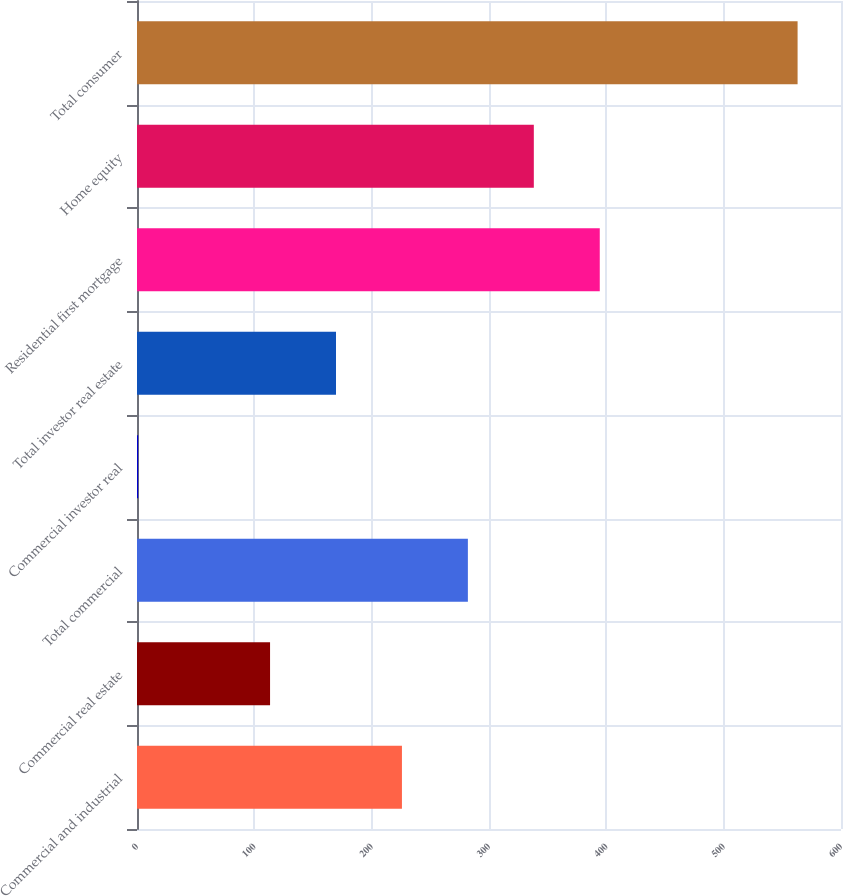<chart> <loc_0><loc_0><loc_500><loc_500><bar_chart><fcel>Commercial and industrial<fcel>Commercial real estate<fcel>Total commercial<fcel>Commercial investor real<fcel>Total investor real estate<fcel>Residential first mortgage<fcel>Home equity<fcel>Total consumer<nl><fcel>225.8<fcel>113.4<fcel>282<fcel>1<fcel>169.6<fcel>394.4<fcel>338.2<fcel>563<nl></chart> 